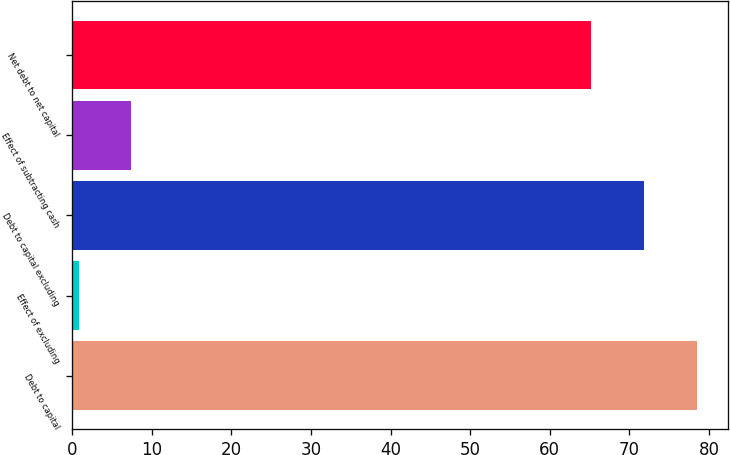<chart> <loc_0><loc_0><loc_500><loc_500><bar_chart><fcel>Debt to capital<fcel>Effect of excluding<fcel>Debt to capital excluding<fcel>Effect of subtracting cash<fcel>Net debt to net capital<nl><fcel>78.46<fcel>0.8<fcel>71.83<fcel>7.43<fcel>65.2<nl></chart> 